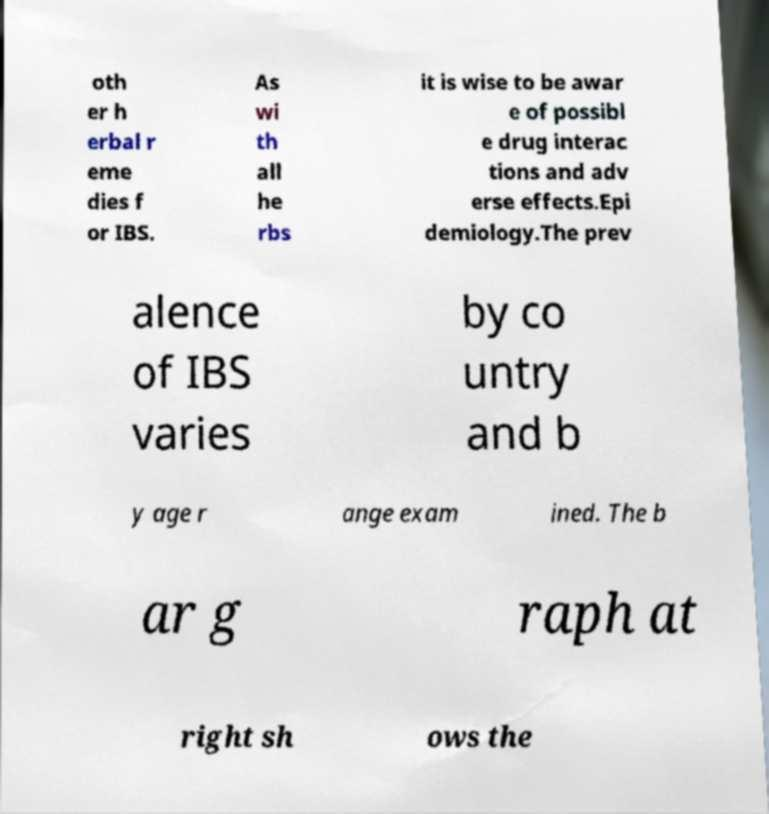Could you extract and type out the text from this image? oth er h erbal r eme dies f or IBS. As wi th all he rbs it is wise to be awar e of possibl e drug interac tions and adv erse effects.Epi demiology.The prev alence of IBS varies by co untry and b y age r ange exam ined. The b ar g raph at right sh ows the 